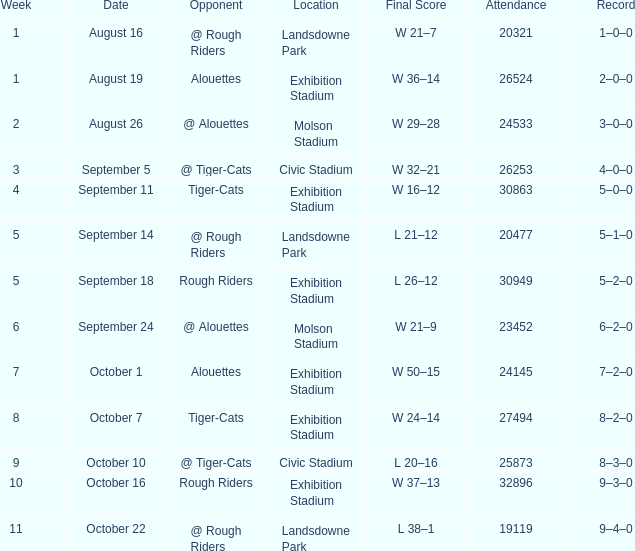How many values for attendance on the date of September 5? 1.0. 